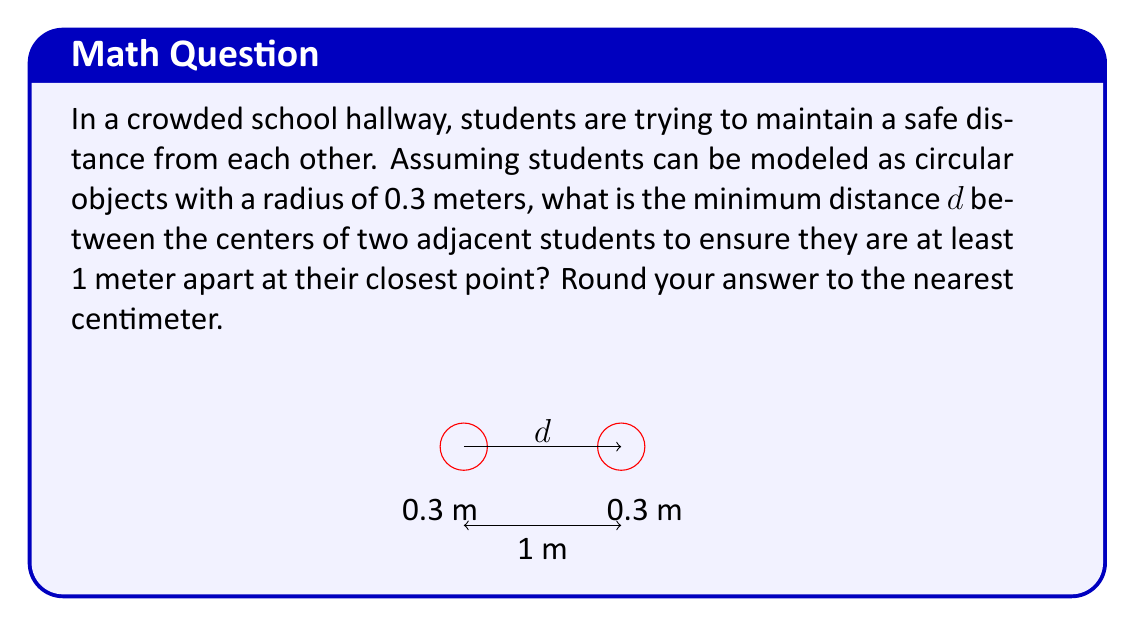Can you solve this math problem? To solve this problem, we need to consider the geometry of the situation:

1) Each student is represented by a circle with a radius of 0.3 meters.

2) We want the edges of these circles to be at least 1 meter apart.

3) The distance we're looking for, $d$, is the distance between the centers of these circles.

We can set up an equation based on these facts:

$$d = 2r + 1$$

Where:
$d$ is the distance between centers
$r$ is the radius of each circle (student)
1 is the minimum distance we want between the edges of the circles

Substituting the known value:

$$d = 2(0.3) + 1$$

$$d = 0.6 + 1 = 1.6$$

Therefore, the centers of the students should be 1.6 meters apart.

Rounding to the nearest centimeter:

$$d ≈ 1.60 \text{ meters}$$

This ensures that even at their closest point, students will be at least 1 meter apart.
Answer: 1.60 meters 